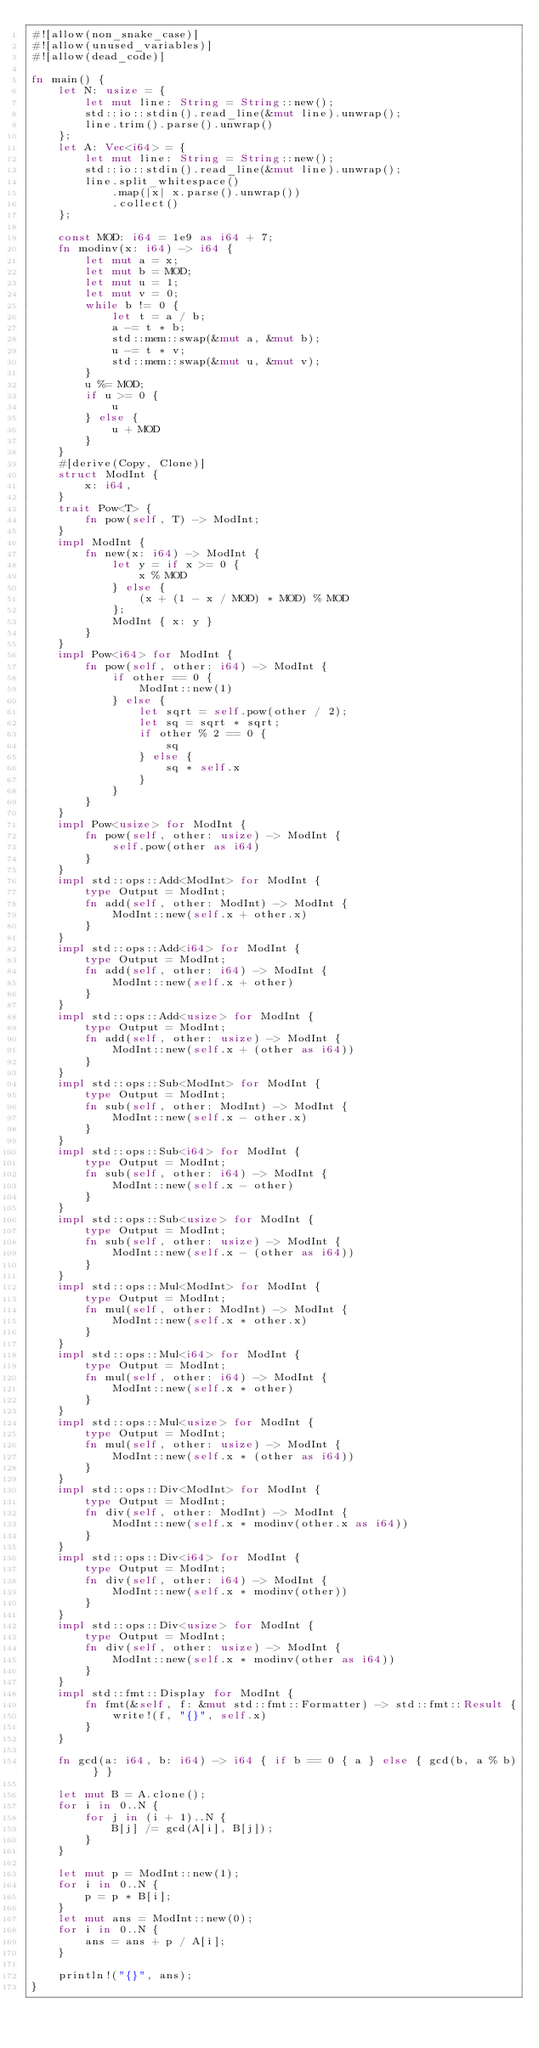Convert code to text. <code><loc_0><loc_0><loc_500><loc_500><_Rust_>#![allow(non_snake_case)]
#![allow(unused_variables)]
#![allow(dead_code)]

fn main() {
    let N: usize = {
        let mut line: String = String::new();
        std::io::stdin().read_line(&mut line).unwrap();
        line.trim().parse().unwrap()
    };
    let A: Vec<i64> = {
        let mut line: String = String::new();
        std::io::stdin().read_line(&mut line).unwrap();
        line.split_whitespace()
            .map(|x| x.parse().unwrap())
            .collect()
    };

    const MOD: i64 = 1e9 as i64 + 7;
    fn modinv(x: i64) -> i64 {
        let mut a = x;
        let mut b = MOD;
        let mut u = 1;
        let mut v = 0;
        while b != 0 {
            let t = a / b;
            a -= t * b;
            std::mem::swap(&mut a, &mut b);
            u -= t * v;
            std::mem::swap(&mut u, &mut v);
        }
        u %= MOD;
        if u >= 0 {
            u
        } else {
            u + MOD
        }
    }
    #[derive(Copy, Clone)]
    struct ModInt {
        x: i64,
    }
    trait Pow<T> {
        fn pow(self, T) -> ModInt;
    }
    impl ModInt {
        fn new(x: i64) -> ModInt {
            let y = if x >= 0 {
                x % MOD
            } else {
                (x + (1 - x / MOD) * MOD) % MOD
            };
            ModInt { x: y }
        }
    }
    impl Pow<i64> for ModInt {
        fn pow(self, other: i64) -> ModInt {
            if other == 0 {
                ModInt::new(1)
            } else {
                let sqrt = self.pow(other / 2);
                let sq = sqrt * sqrt;
                if other % 2 == 0 {
                    sq
                } else {
                    sq * self.x
                }
            }
        }
    }
    impl Pow<usize> for ModInt {
        fn pow(self, other: usize) -> ModInt {
            self.pow(other as i64)
        }
    }
    impl std::ops::Add<ModInt> for ModInt {
        type Output = ModInt;
        fn add(self, other: ModInt) -> ModInt {
            ModInt::new(self.x + other.x)
        }
    }
    impl std::ops::Add<i64> for ModInt {
        type Output = ModInt;
        fn add(self, other: i64) -> ModInt {
            ModInt::new(self.x + other)
        }
    }
    impl std::ops::Add<usize> for ModInt {
        type Output = ModInt;
        fn add(self, other: usize) -> ModInt {
            ModInt::new(self.x + (other as i64))
        }
    }
    impl std::ops::Sub<ModInt> for ModInt {
        type Output = ModInt;
        fn sub(self, other: ModInt) -> ModInt {
            ModInt::new(self.x - other.x)
        }
    }
    impl std::ops::Sub<i64> for ModInt {
        type Output = ModInt;
        fn sub(self, other: i64) -> ModInt {
            ModInt::new(self.x - other)
        }
    }
    impl std::ops::Sub<usize> for ModInt {
        type Output = ModInt;
        fn sub(self, other: usize) -> ModInt {
            ModInt::new(self.x - (other as i64))
        }
    }
    impl std::ops::Mul<ModInt> for ModInt {
        type Output = ModInt;
        fn mul(self, other: ModInt) -> ModInt {
            ModInt::new(self.x * other.x)
        }
    }
    impl std::ops::Mul<i64> for ModInt {
        type Output = ModInt;
        fn mul(self, other: i64) -> ModInt {
            ModInt::new(self.x * other)
        }
    }
    impl std::ops::Mul<usize> for ModInt {
        type Output = ModInt;
        fn mul(self, other: usize) -> ModInt {
            ModInt::new(self.x * (other as i64))
        }
    }
    impl std::ops::Div<ModInt> for ModInt {
        type Output = ModInt;
        fn div(self, other: ModInt) -> ModInt {
            ModInt::new(self.x * modinv(other.x as i64))
        }
    }
    impl std::ops::Div<i64> for ModInt {
        type Output = ModInt;
        fn div(self, other: i64) -> ModInt {
            ModInt::new(self.x * modinv(other))
        }
    }
    impl std::ops::Div<usize> for ModInt {
        type Output = ModInt;
        fn div(self, other: usize) -> ModInt {
            ModInt::new(self.x * modinv(other as i64))
        }
    }
    impl std::fmt::Display for ModInt {
        fn fmt(&self, f: &mut std::fmt::Formatter) -> std::fmt::Result {
            write!(f, "{}", self.x)
        }
    }

    fn gcd(a: i64, b: i64) -> i64 { if b == 0 { a } else { gcd(b, a % b) } }

    let mut B = A.clone();
    for i in 0..N {
        for j in (i + 1)..N {
            B[j] /= gcd(A[i], B[j]);
        }
    }

    let mut p = ModInt::new(1);
    for i in 0..N {
        p = p * B[i];
    }
    let mut ans = ModInt::new(0);
    for i in 0..N {
        ans = ans + p / A[i];
    }

    println!("{}", ans);
}</code> 